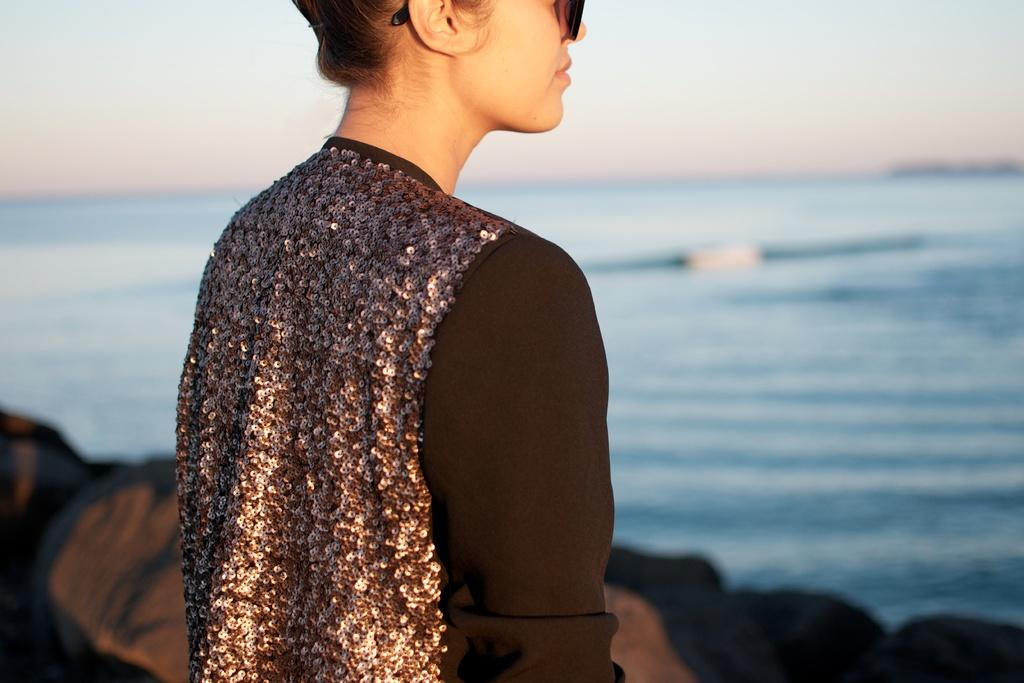What is the main subject of the image? There is a woman standing in the image. What type of natural features can be seen in the image? There are rocks visible in the image, and there is a large water body present. What is visible in the sky in the image? The sky is visible in the image. Can you tell me how many owls are perched on the woman's neck in the image? There are no owls present in the image, and the woman's neck is not visible. What does the woman's uncle say about the water body in the image? There is no information about the woman's uncle or any conversation in the image. 